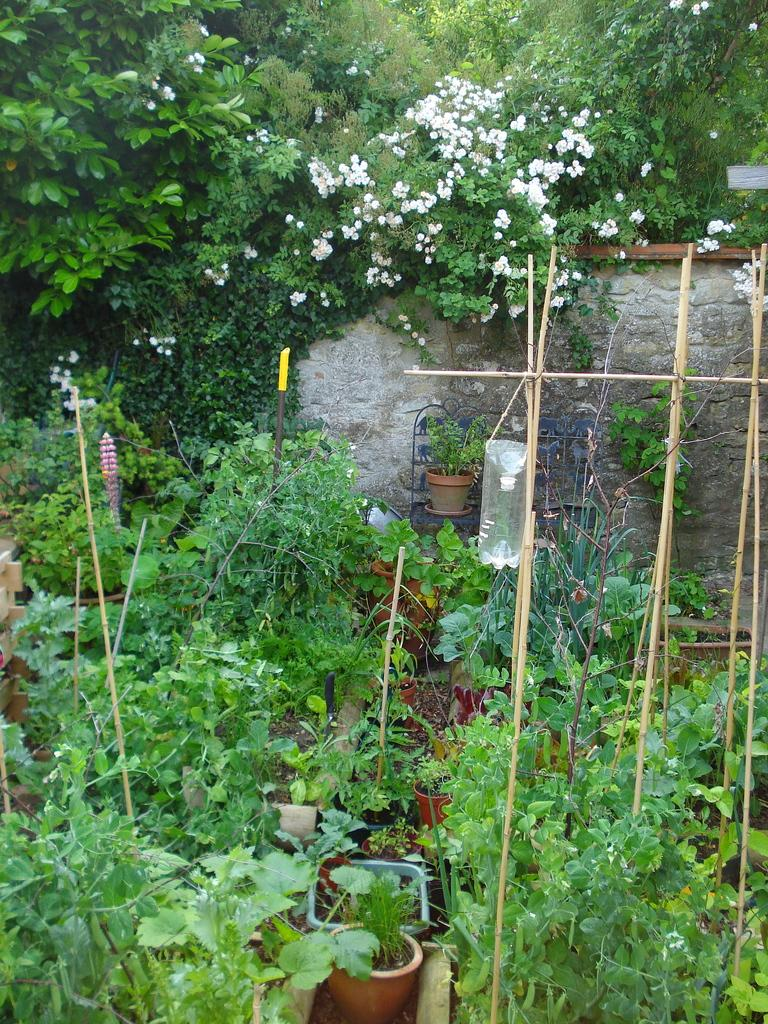What type of objects are in the pots in the image? There are plants in the pots in the image. What is located behind the pots with plants? There is a wall visible behind the plants. What type of vegetation can be seen in the image besides the plants in the pots? There are trees visible in the image. What type of current can be seen flowing through the image? There is no current visible in the image; it features pots with plants, a wall, and trees. 